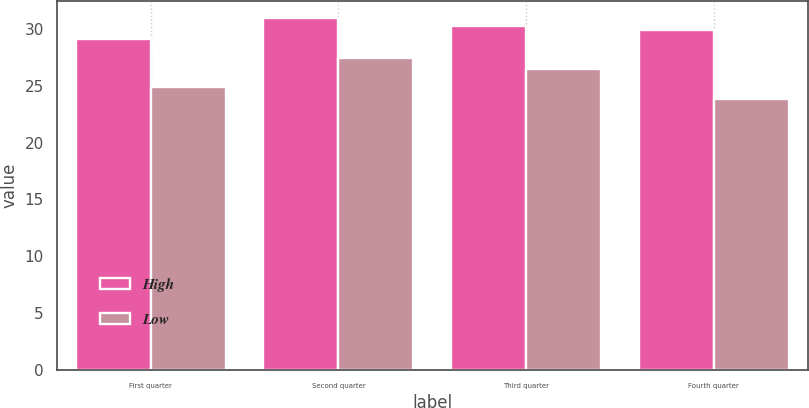Convert chart to OTSL. <chart><loc_0><loc_0><loc_500><loc_500><stacked_bar_chart><ecel><fcel>First quarter<fcel>Second quarter<fcel>Third quarter<fcel>Fourth quarter<nl><fcel>High<fcel>29.1<fcel>30.96<fcel>30.29<fcel>29.95<nl><fcel>Low<fcel>24.9<fcel>27.42<fcel>26.5<fcel>23.87<nl></chart> 